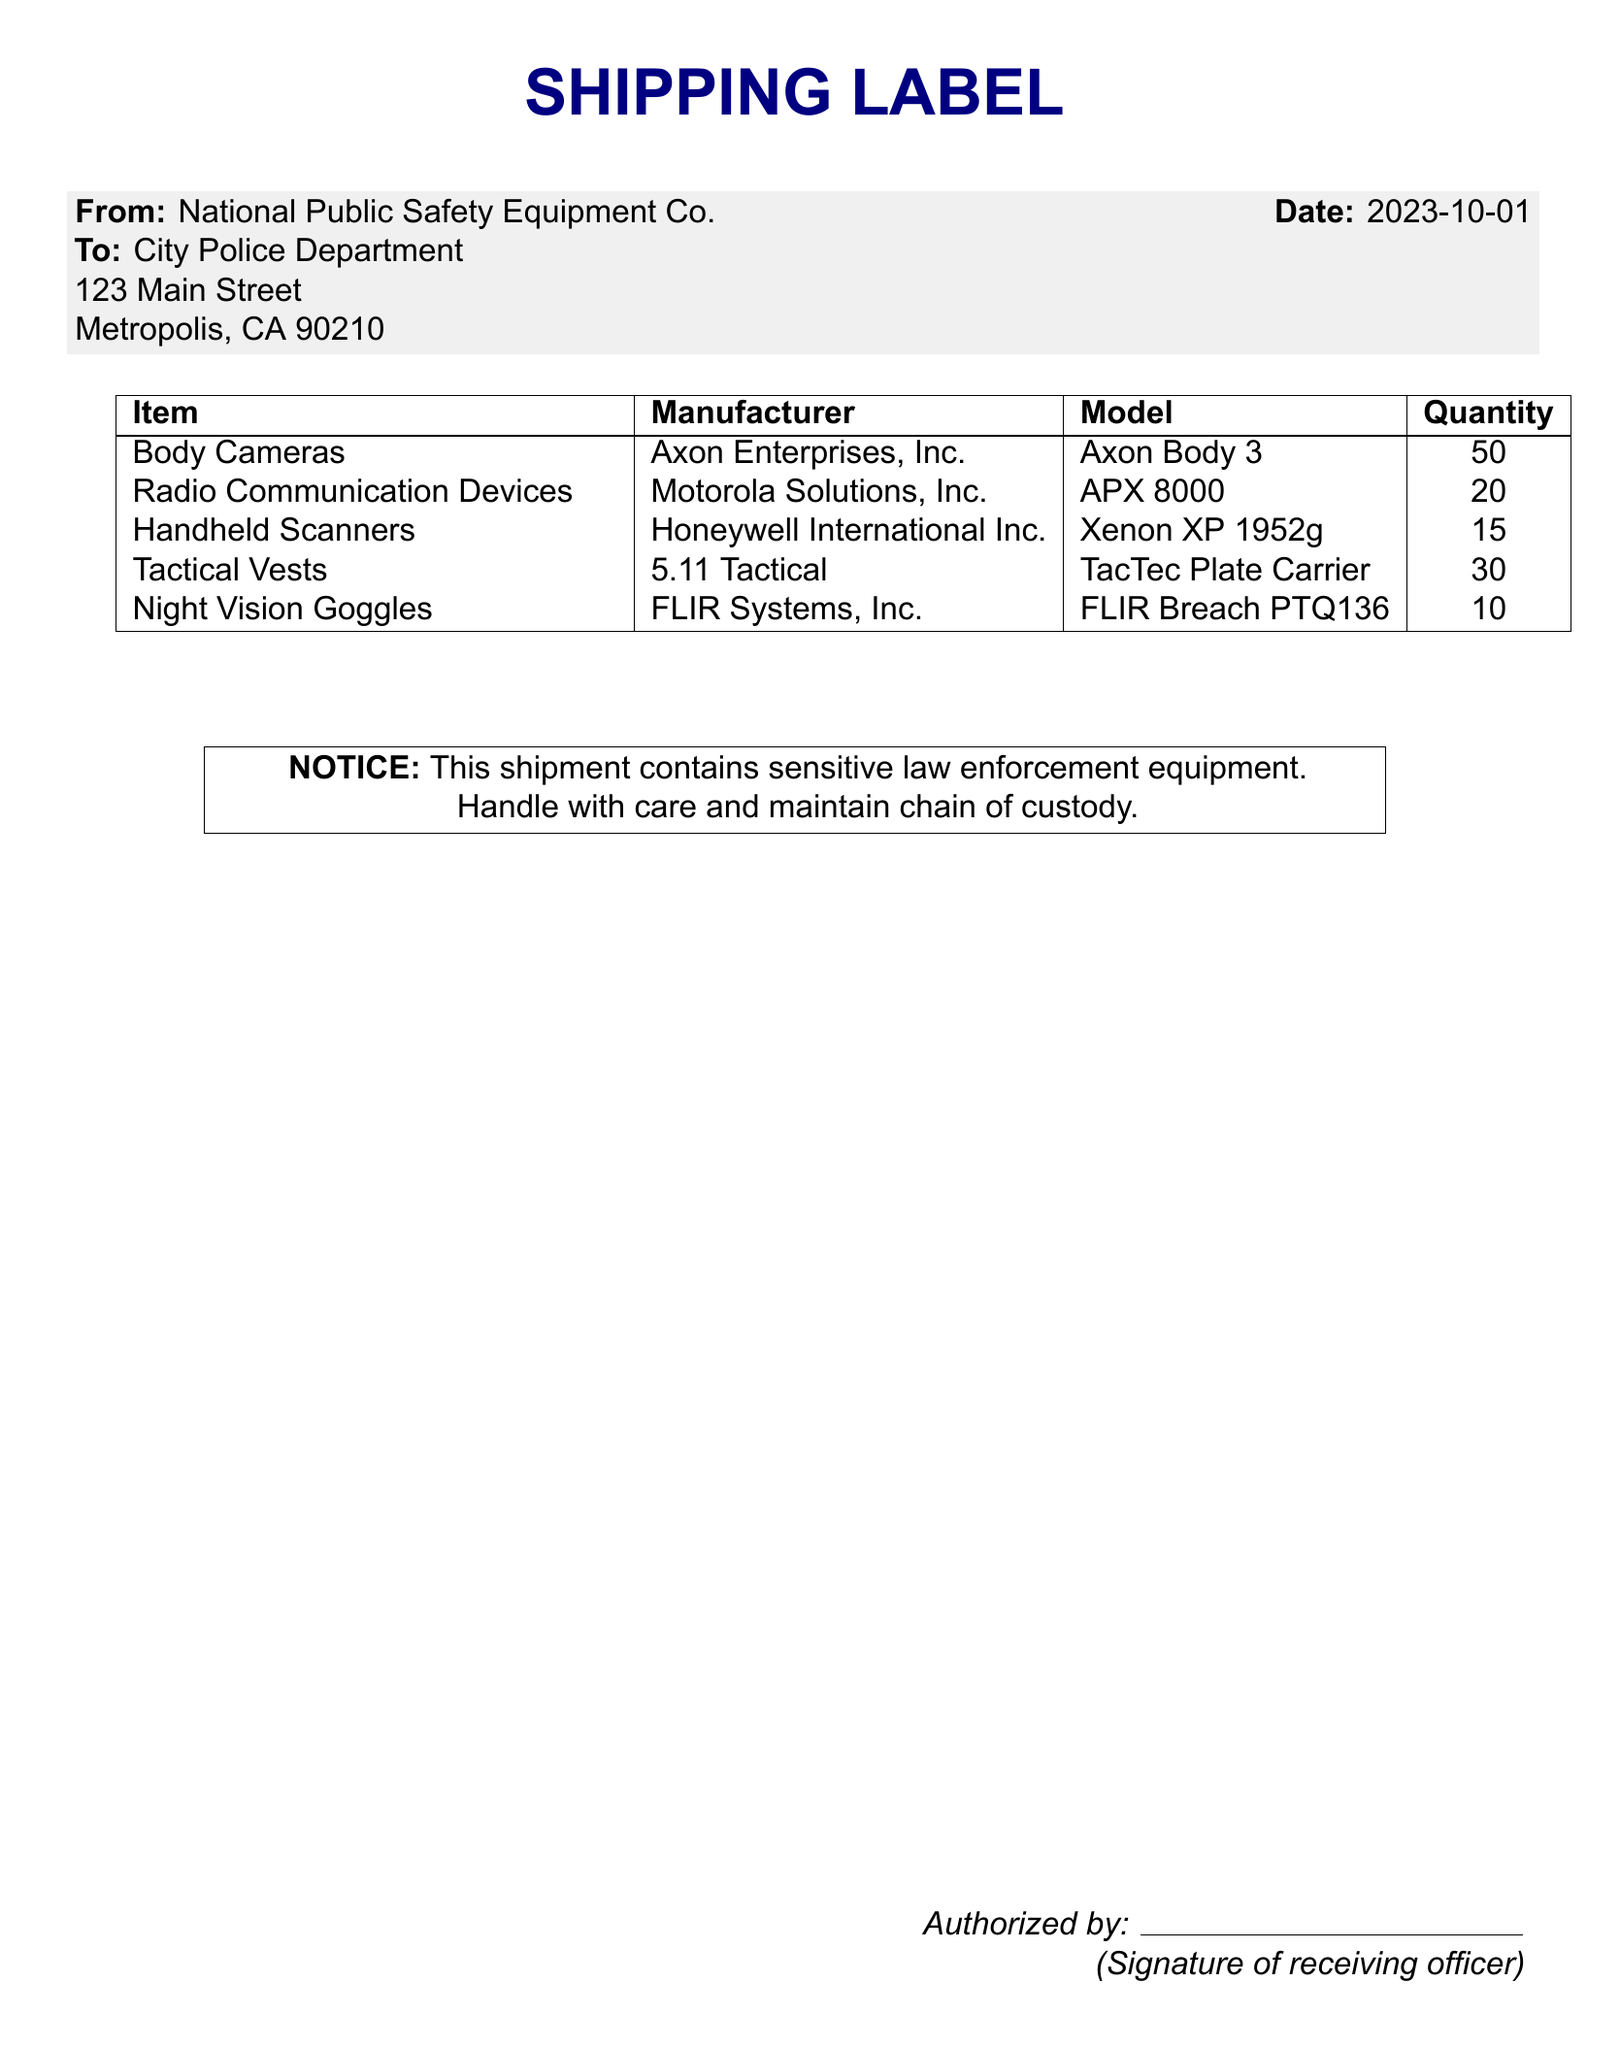What is the date of the shipment? The date of the shipment is listed in the document under 'Date,' which is 2023-10-01.
Answer: 2023-10-01 Who is the sender of the shipment? The sender of the shipment is provided in the 'From' section, which states National Public Safety Equipment Co.
Answer: National Public Safety Equipment Co How many body cameras are included in the shipment? The quantity of body cameras is specified in the table under 'Quantity,' showing 50.
Answer: 50 What is the model of the radio communication devices? The model of the radio communication devices is mentioned in the table under 'Model,' which is APX 8000.
Answer: APX 8000 How many tactical vests are shipped? The quantity of tactical vests is detailed in the table under 'Quantity,' which is 30.
Answer: 30 What notice is included in the document? The notice is included in the text box, indicating that the shipment contains sensitive law enforcement equipment.
Answer: This shipment contains sensitive law enforcement equipment What is the quantity of night vision goggles? The quantity for night vision goggles is listed in the quantity column of the table, stating 10.
Answer: 10 Who needs to sign upon receipt of the shipment? The document specifies that the receiving officer needs to sign as indicated in the 'Authorized by' section.
Answer: Receiving officer What company manufactures the handheld scanners? The manufacturer of the handheld scanners is provided in the table, which is Honeywell International Inc.
Answer: Honeywell International Inc 